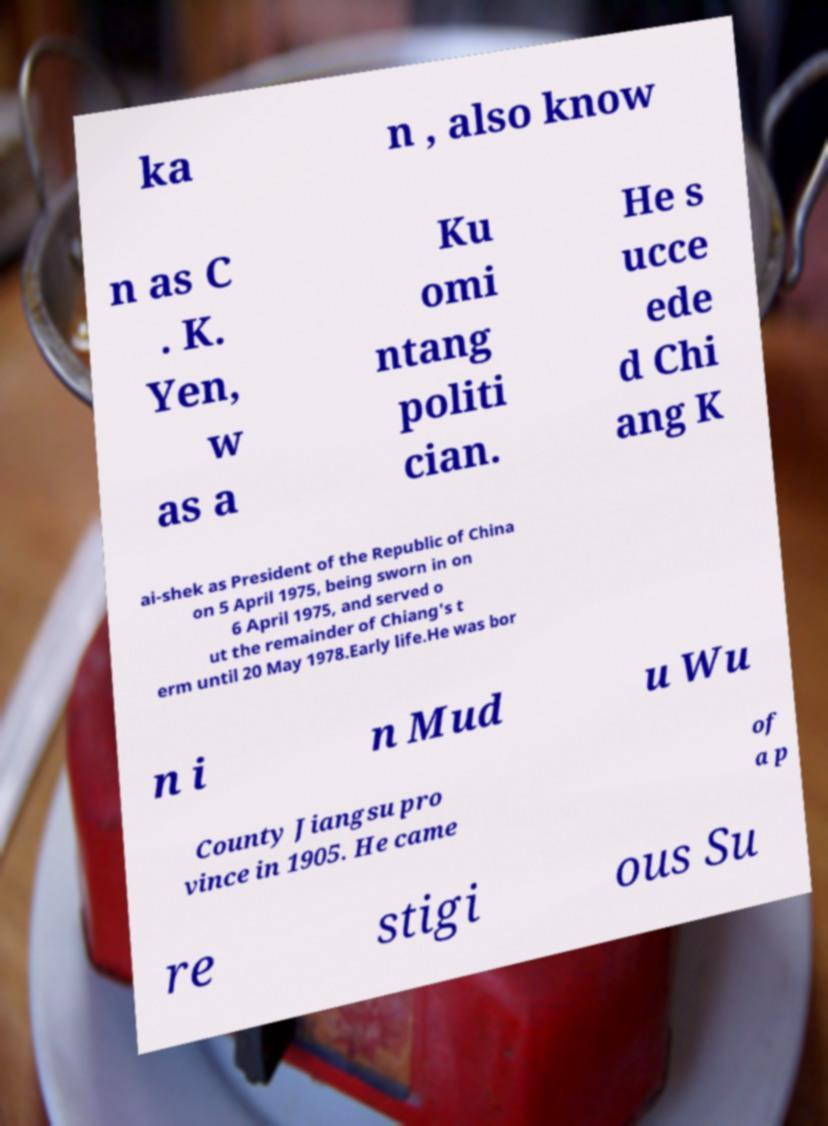I need the written content from this picture converted into text. Can you do that? ka n , also know n as C . K. Yen, w as a Ku omi ntang politi cian. He s ucce ede d Chi ang K ai-shek as President of the Republic of China on 5 April 1975, being sworn in on 6 April 1975, and served o ut the remainder of Chiang's t erm until 20 May 1978.Early life.He was bor n i n Mud u Wu County Jiangsu pro vince in 1905. He came of a p re stigi ous Su 